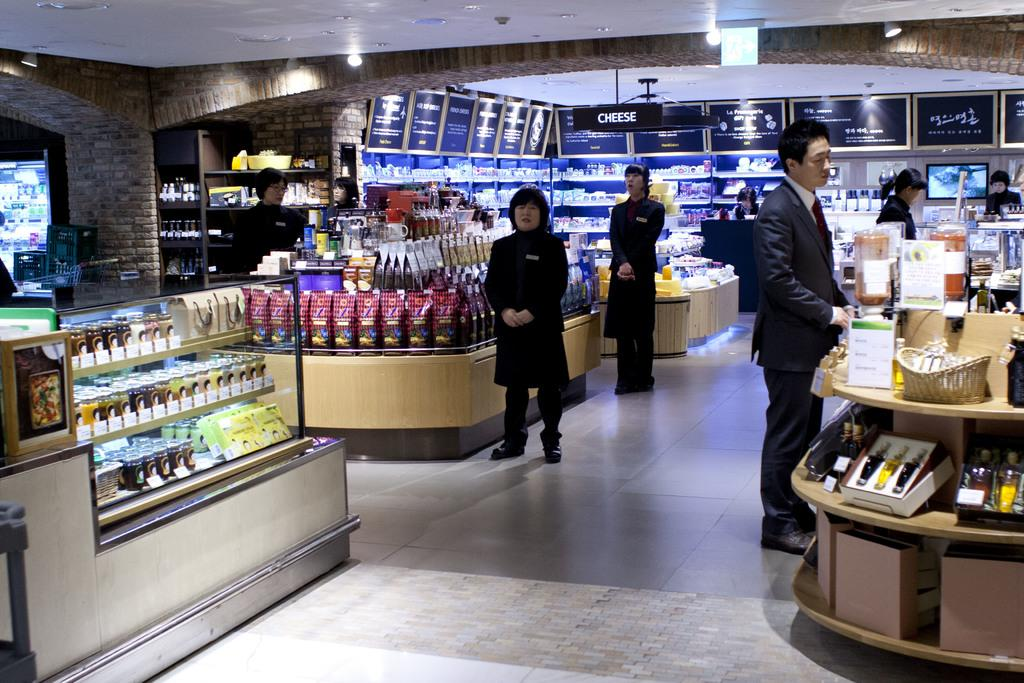What type of location is depicted in the image? The image shows an inner view of a store. Are there any people present in the store? Yes, there are people standing in the store. What can be seen on the shelves or displays in the store? There are items visible in the store. What is being displayed on the television in the store? The television displaying something in the store. How is the store illuminated? There are lights on the ceiling of the store. What type of invention is being demonstrated by the bears in the store? There are no bears present in the image, and therefore no invention is being demonstrated. 